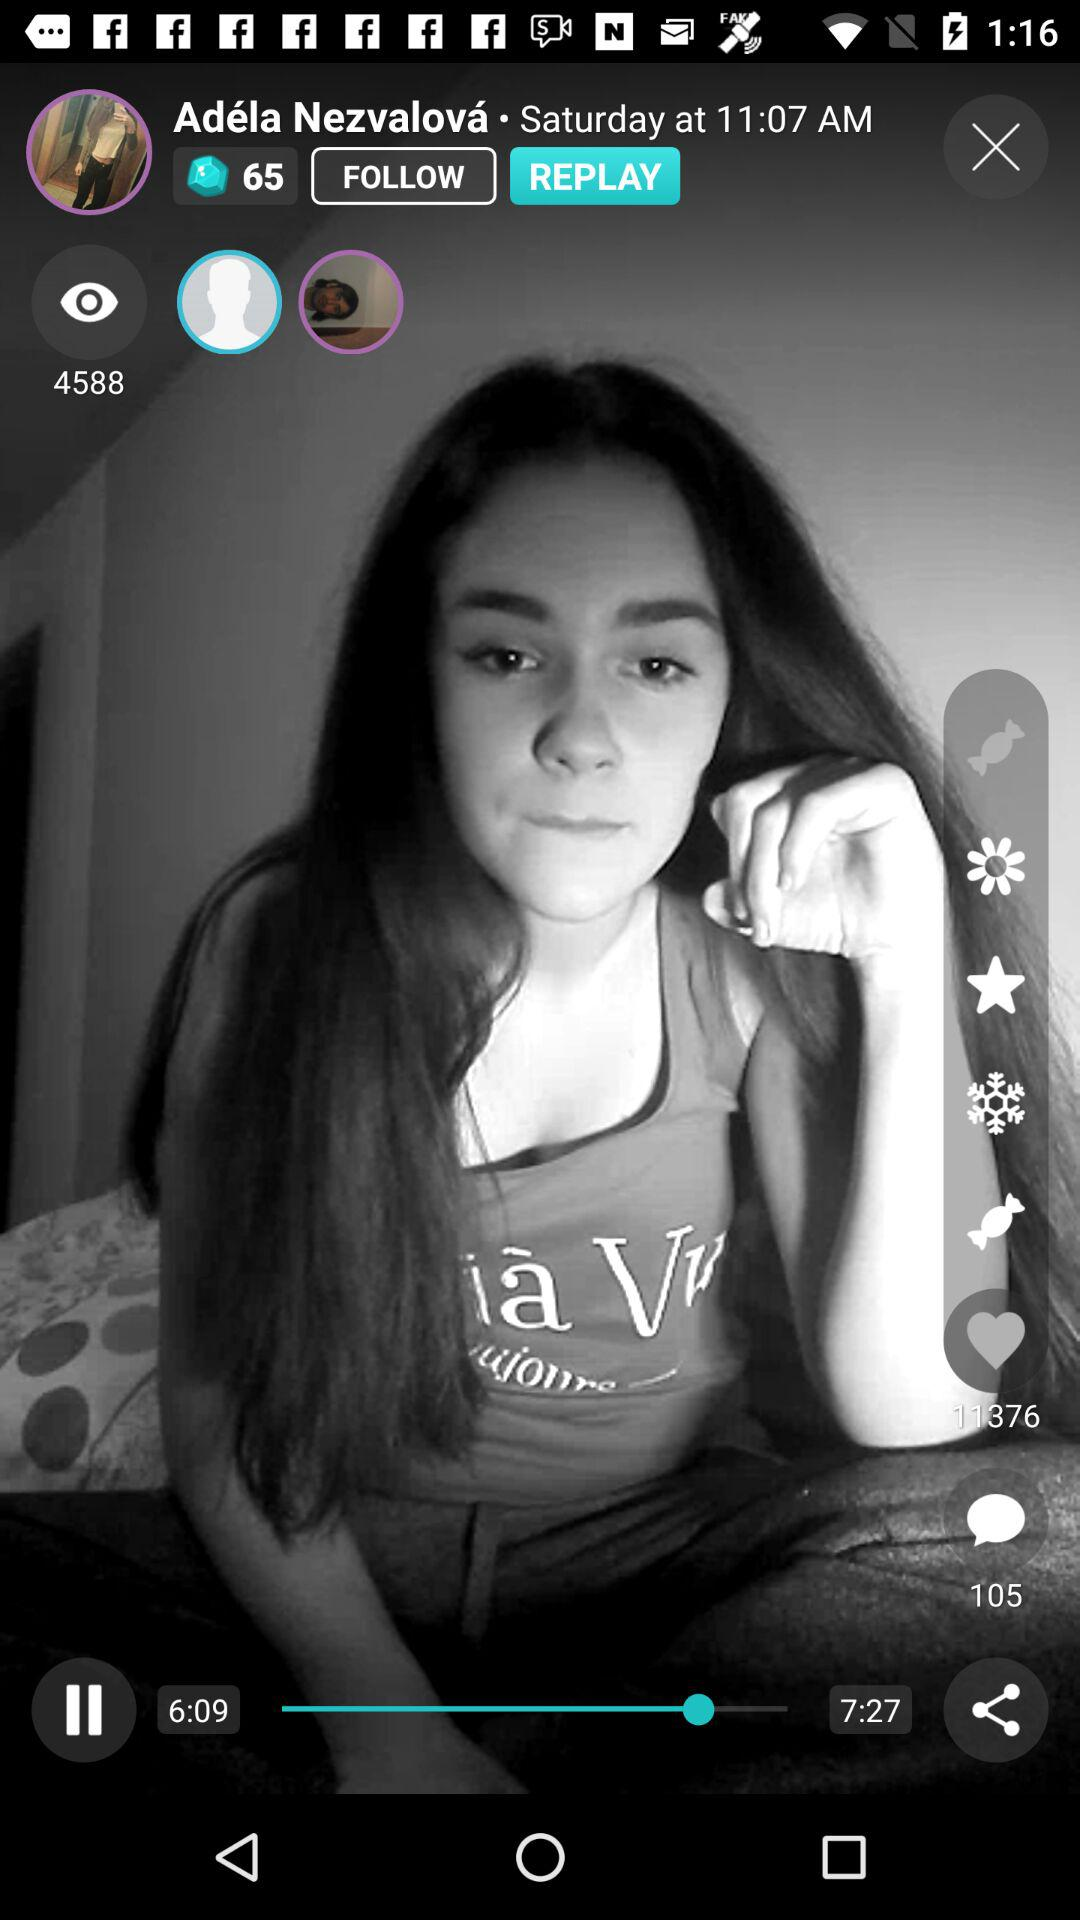How many views are there? There are 4588 views. 